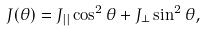<formula> <loc_0><loc_0><loc_500><loc_500>J ( \theta ) = J _ { | | } \cos ^ { 2 } \theta + J _ { \perp } \sin ^ { 2 } \theta ,</formula> 